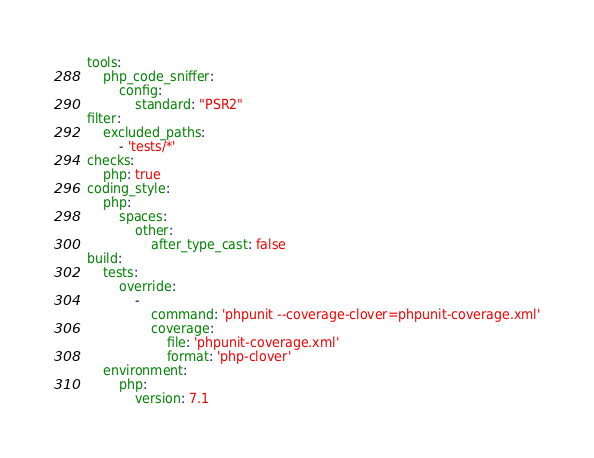<code> <loc_0><loc_0><loc_500><loc_500><_YAML_>tools:
    php_code_sniffer:
        config:
            standard: "PSR2"
filter:
    excluded_paths:
        - 'tests/*'
checks:
    php: true
coding_style:
    php:
        spaces:
            other:
                after_type_cast: false
build:
    tests:
        override:
            -
                command: 'phpunit --coverage-clover=phpunit-coverage.xml'
                coverage:
                    file: 'phpunit-coverage.xml'
                    format: 'php-clover'
    environment:
        php:
            version: 7.1
</code> 